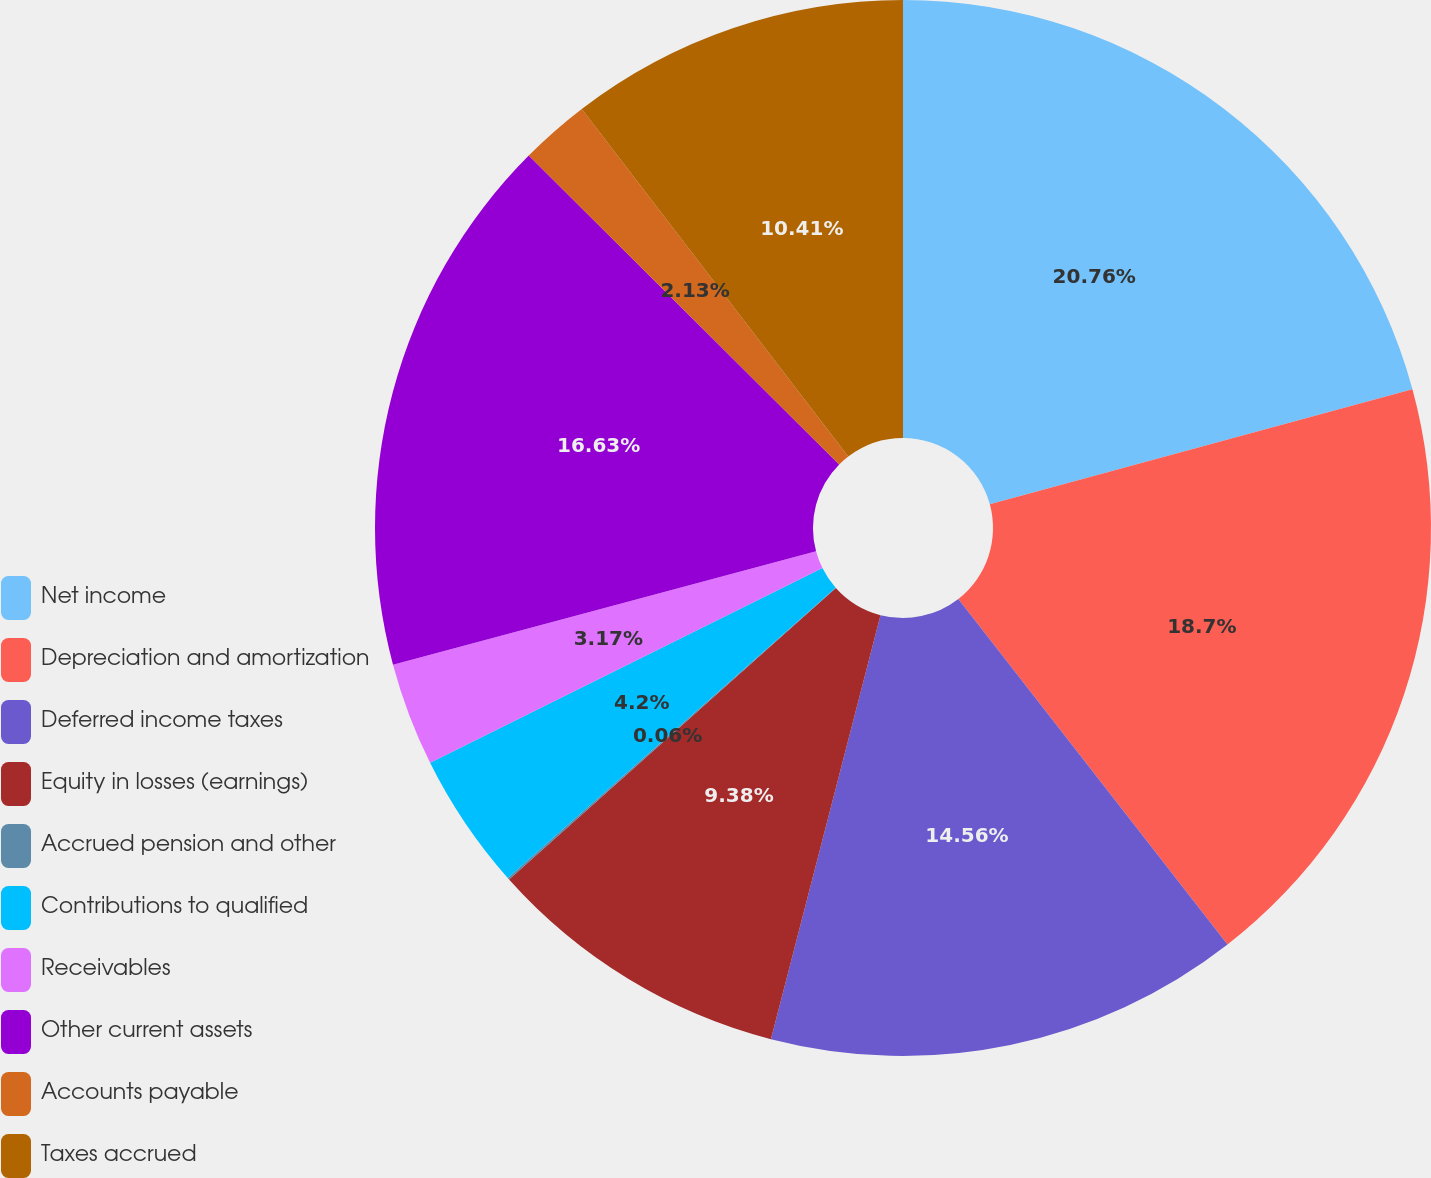Convert chart. <chart><loc_0><loc_0><loc_500><loc_500><pie_chart><fcel>Net income<fcel>Depreciation and amortization<fcel>Deferred income taxes<fcel>Equity in losses (earnings)<fcel>Accrued pension and other<fcel>Contributions to qualified<fcel>Receivables<fcel>Other current assets<fcel>Accounts payable<fcel>Taxes accrued<nl><fcel>20.77%<fcel>18.7%<fcel>14.56%<fcel>9.38%<fcel>0.06%<fcel>4.2%<fcel>3.17%<fcel>16.63%<fcel>2.13%<fcel>10.41%<nl></chart> 